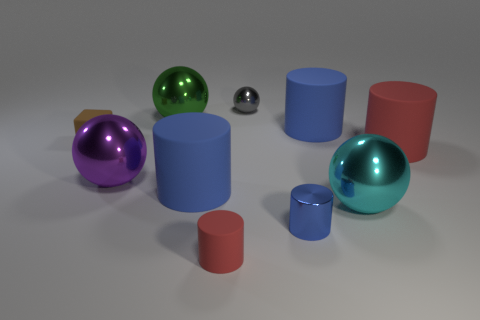There is another cylinder that is the same color as the tiny matte cylinder; what material is it?
Ensure brevity in your answer.  Rubber. How many other things are there of the same color as the metallic cylinder?
Give a very brief answer. 2. Do the brown thing and the gray shiny thing have the same size?
Your answer should be compact. Yes. What material is the red cylinder that is the same size as the purple metal thing?
Your response must be concise. Rubber. How many other matte objects have the same shape as the big red thing?
Your answer should be very brief. 3. The green object that is the same material as the purple thing is what size?
Your answer should be very brief. Large. There is a blue cylinder that is both behind the small shiny cylinder and right of the small red matte cylinder; what material is it?
Ensure brevity in your answer.  Rubber. There is a large red thing that is the same shape as the tiny red thing; what is its material?
Your answer should be very brief. Rubber. There is a tiny brown object; is its shape the same as the big blue matte object in front of the matte cube?
Make the answer very short. No. What is the shape of the big blue matte object left of the big blue rubber cylinder that is behind the large rubber cylinder left of the shiny cylinder?
Your answer should be very brief. Cylinder. 